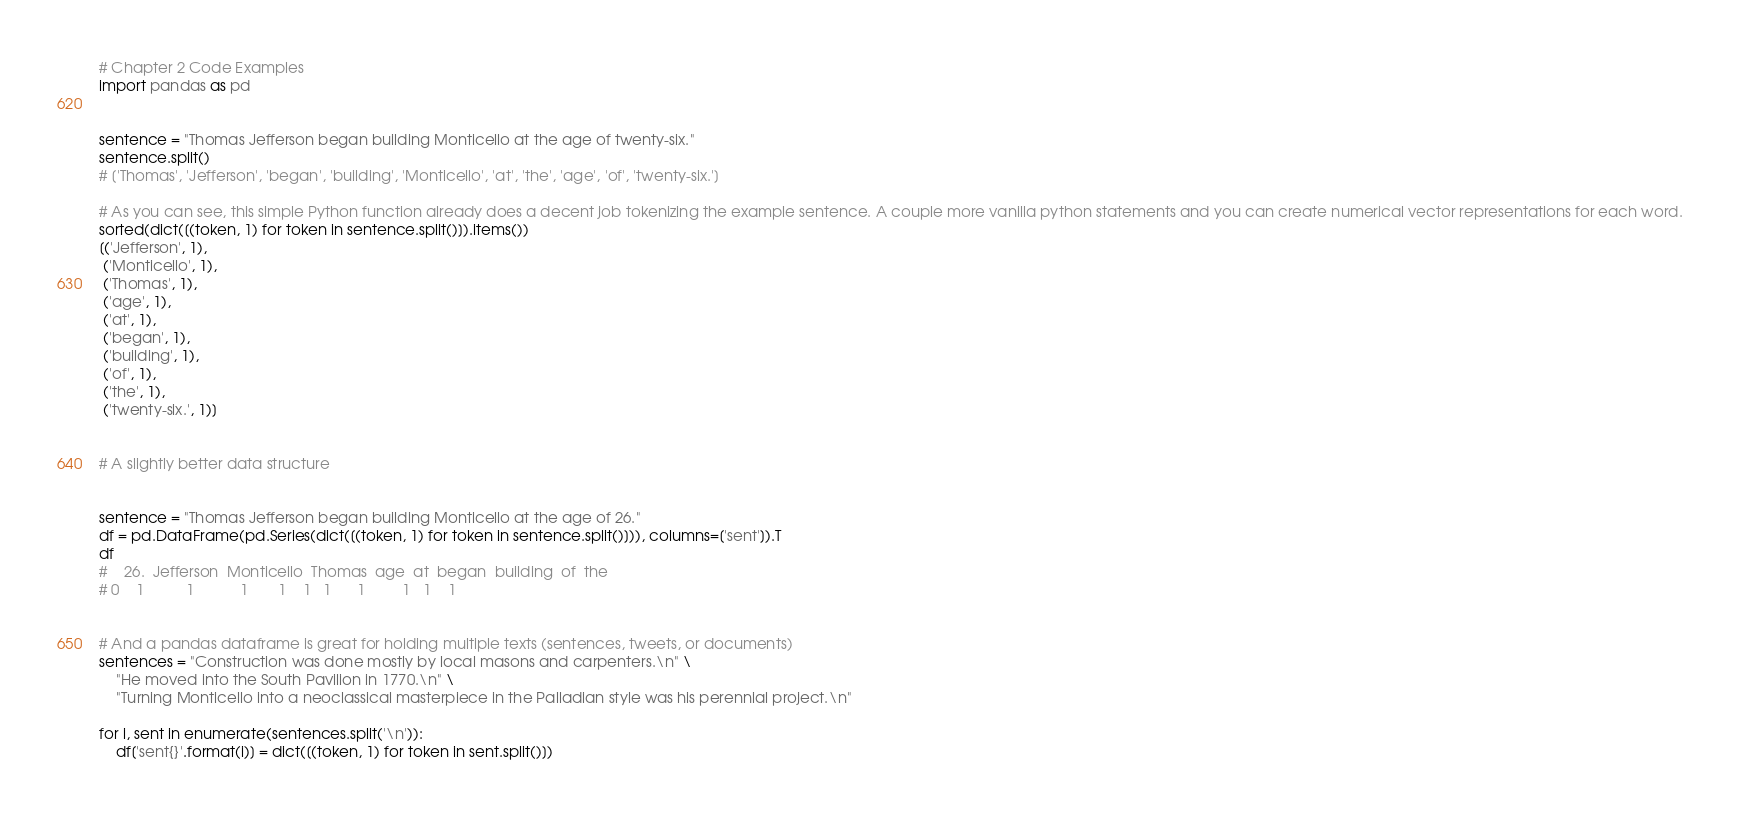<code> <loc_0><loc_0><loc_500><loc_500><_Python_># Chapter 2 Code Examples
import pandas as pd


sentence = "Thomas Jefferson began building Monticello at the age of twenty-six."
sentence.split()
# ['Thomas', 'Jefferson', 'began', 'building', 'Monticello', 'at', 'the', 'age', 'of', 'twenty-six.']

# As you can see, this simple Python function already does a decent job tokenizing the example sentence. A couple more vanilla python statements and you can create numerical vector representations for each word.
sorted(dict([(token, 1) for token in sentence.split()]).items())
[('Jefferson', 1),
 ('Monticello', 1),
 ('Thomas', 1),
 ('age', 1),
 ('at', 1),
 ('began', 1),
 ('building', 1),
 ('of', 1),
 ('the', 1),
 ('twenty-six.', 1)]


# A slightly better data structure


sentence = "Thomas Jefferson began building Monticello at the age of 26."
df = pd.DataFrame(pd.Series(dict([(token, 1) for token in sentence.split()])), columns=['sent']).T
df
#    26.  Jefferson  Monticello  Thomas  age  at  began  building  of  the
# 0    1          1           1       1    1   1      1         1   1    1


# And a pandas dataframe is great for holding multiple texts (sentences, tweets, or documents)
sentences = "Construction was done mostly by local masons and carpenters.\n" \
    "He moved into the South Pavilion in 1770.\n" \
    "Turning Monticello into a neoclassical masterpiece in the Palladian style was his perennial project.\n"

for i, sent in enumerate(sentences.split('\n')):
    df['sent{}'.format(i)] = dict([(token, 1) for token in sent.split()])
</code> 